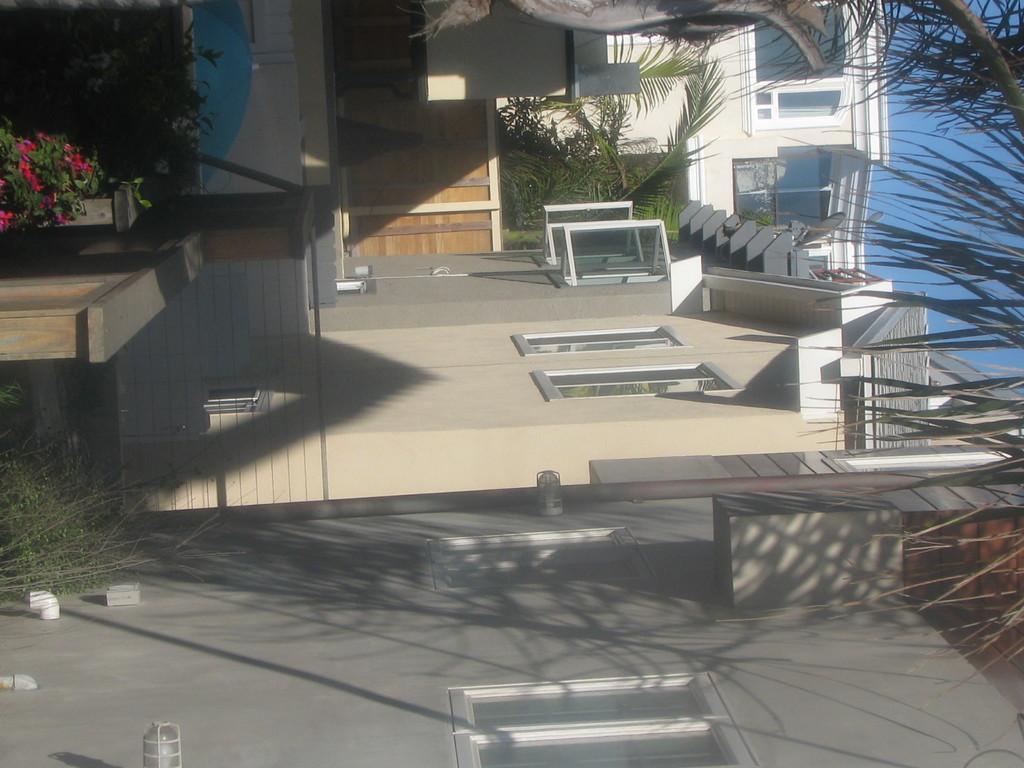Describe this image in one or two sentences. It is an inverted picture,there are beautiful houses in a row and to one of the house the windows are open and beside the houses there are beautiful trees. 